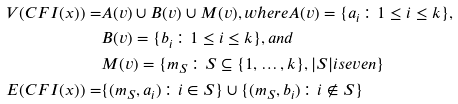Convert formula to latex. <formula><loc_0><loc_0><loc_500><loc_500>V ( C F I ( x ) ) = & A ( v ) \cup B ( v ) \cup M ( v ) , w h e r e A ( v ) = \{ a _ { i } \colon 1 \leq i \leq k \} , \\ & B ( v ) = \{ b _ { i } \colon 1 \leq i \leq k \} , a n d \\ & M ( v ) = \{ m _ { S } \colon S \subseteq \{ 1 , \dots , k \} , | S | i s e v e n \} \\ E ( C F I ( x ) ) = & \{ ( m _ { S } , a _ { i } ) \colon i \in S \} \cup \{ ( m _ { S } , b _ { i } ) \colon i \notin S \}</formula> 